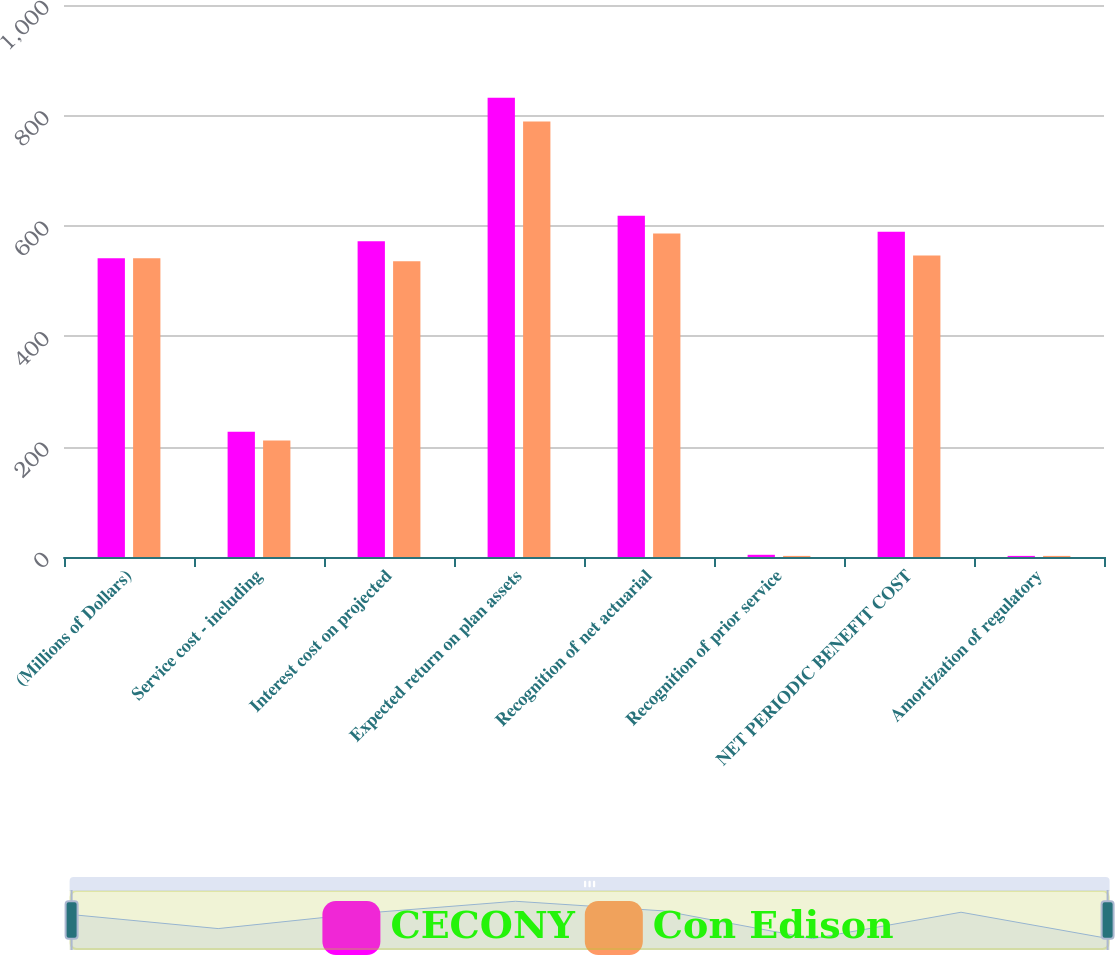<chart> <loc_0><loc_0><loc_500><loc_500><stacked_bar_chart><ecel><fcel>(Millions of Dollars)<fcel>Service cost - including<fcel>Interest cost on projected<fcel>Expected return on plan assets<fcel>Recognition of net actuarial<fcel>Recognition of prior service<fcel>NET PERIODIC BENEFIT COST<fcel>Amortization of regulatory<nl><fcel>CECONY<fcel>541<fcel>227<fcel>572<fcel>832<fcel>618<fcel>4<fcel>589<fcel>2<nl><fcel>Con Edison<fcel>541<fcel>211<fcel>536<fcel>789<fcel>586<fcel>2<fcel>546<fcel>2<nl></chart> 